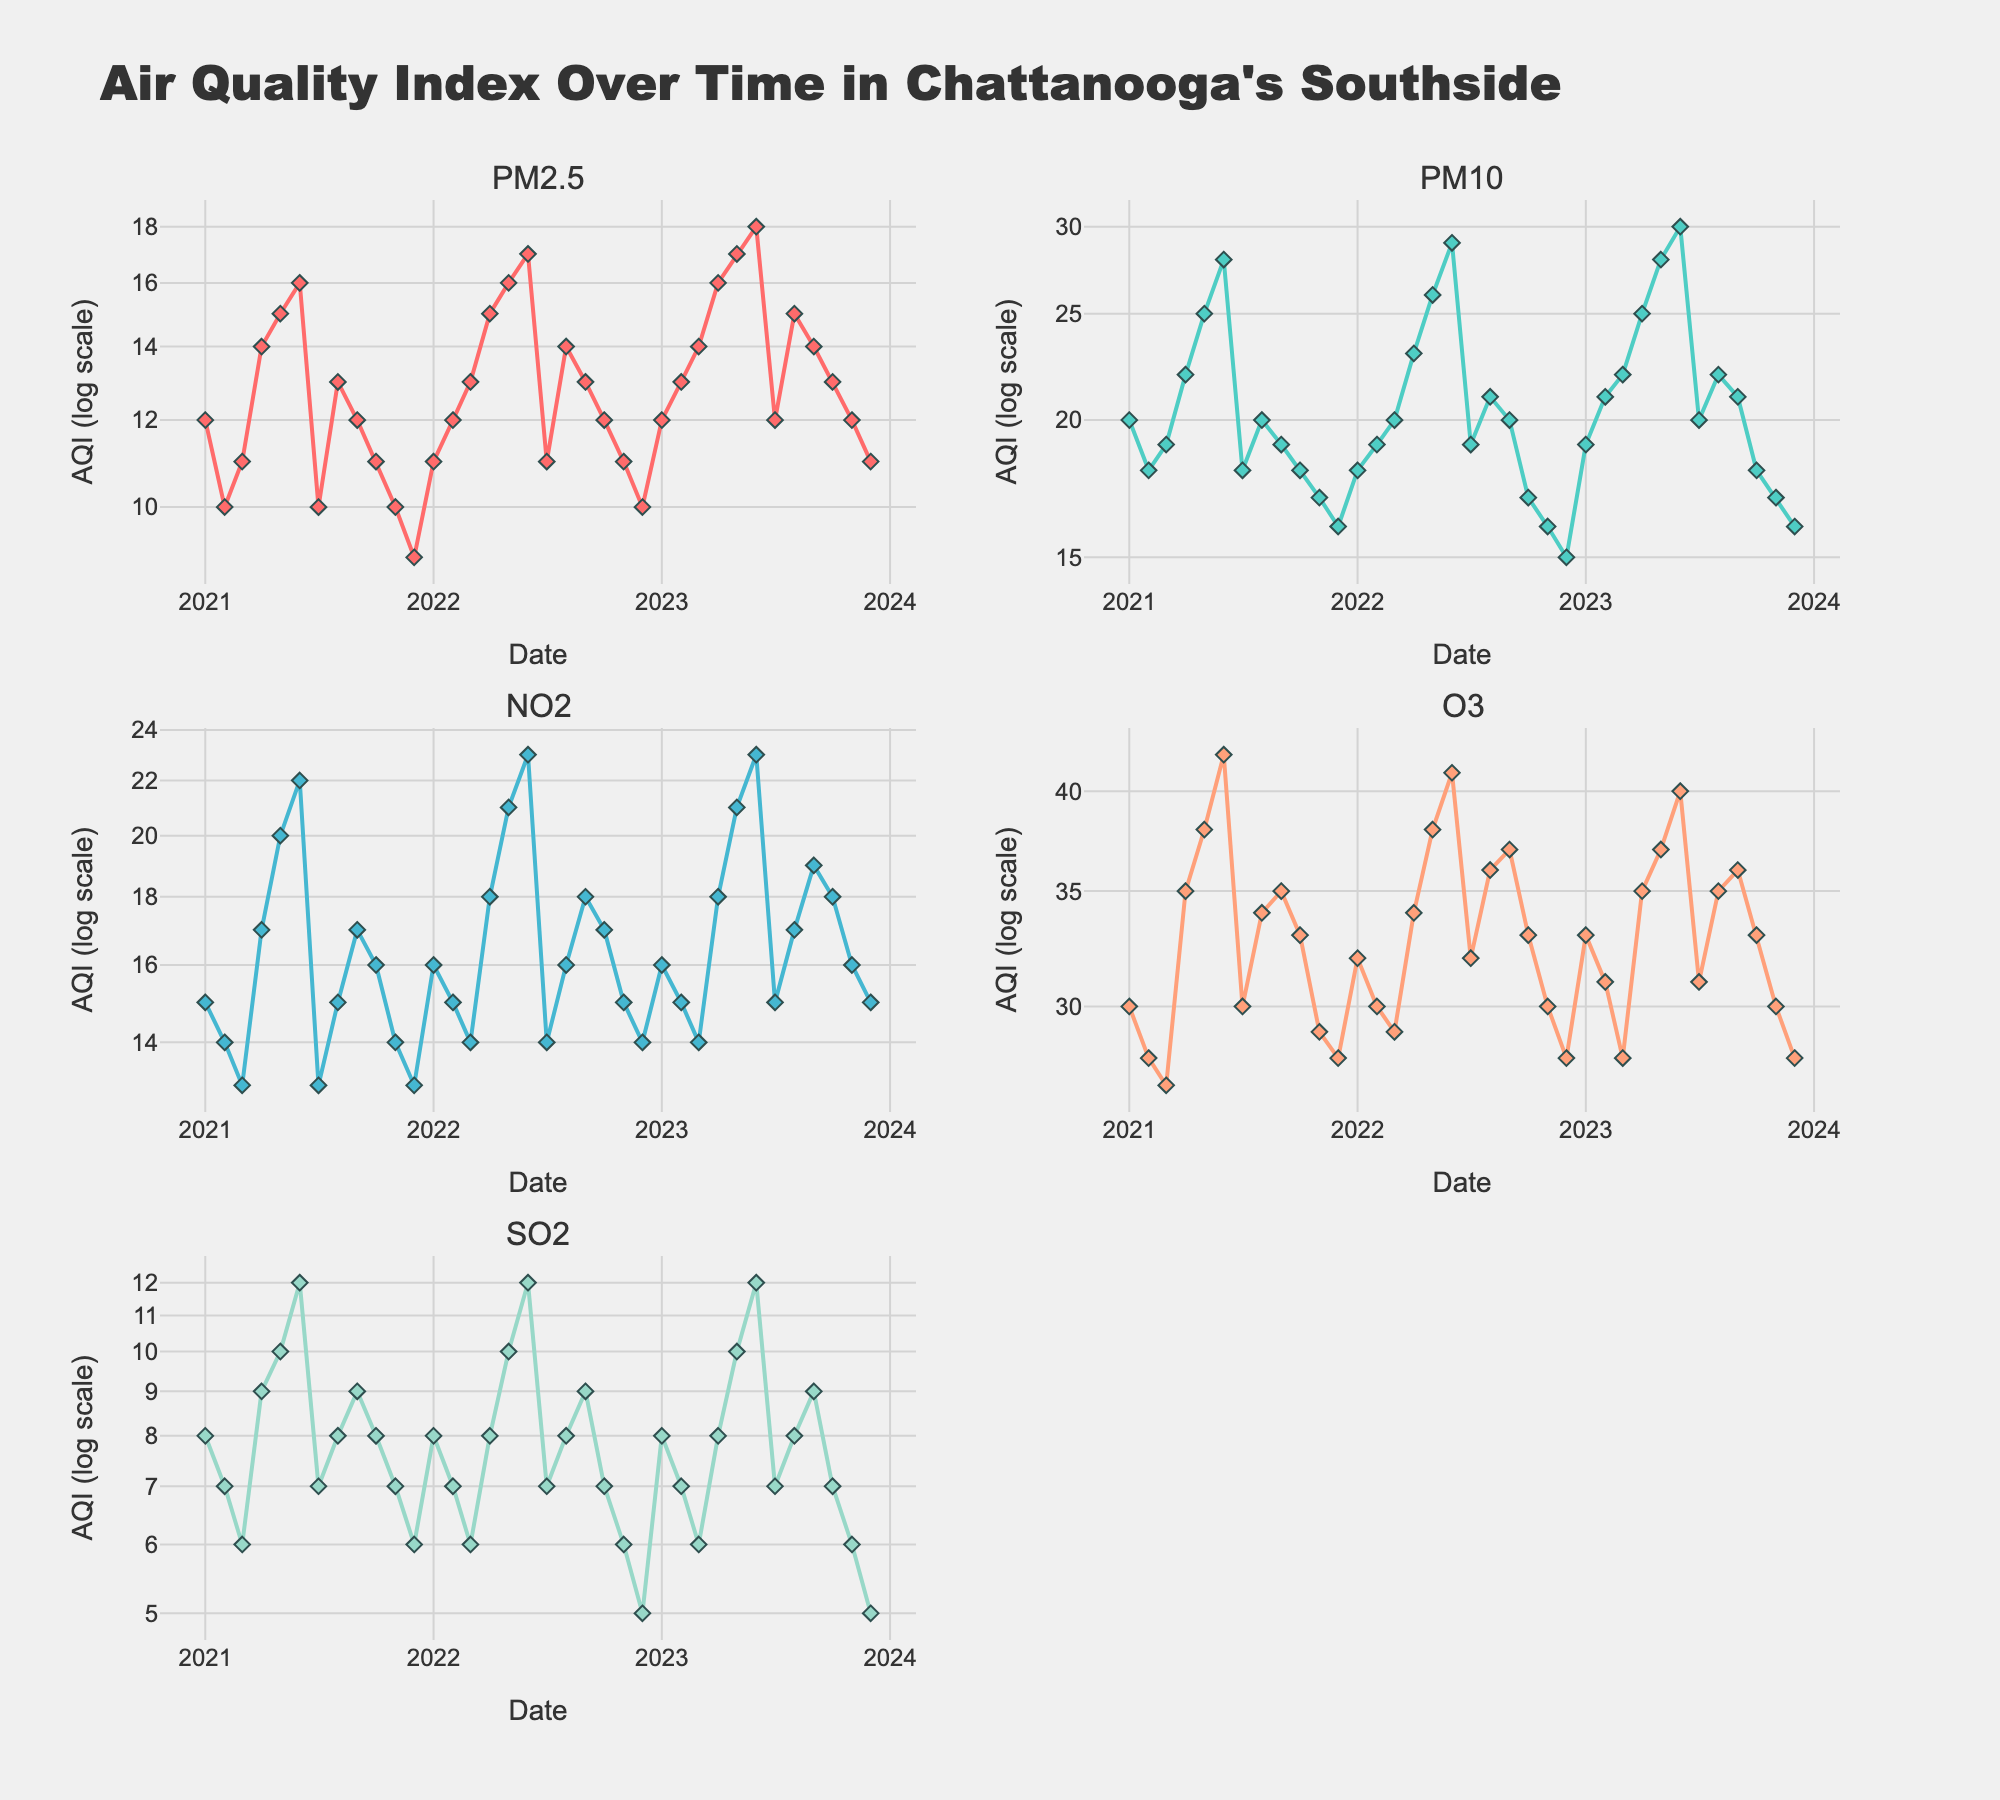What is the title of the plot? The title of the plot is located at the top of the figure, which provides an overview of what the plot represents.
Answer: Air Quality Index Over Time in Chattanooga's Southside What pollutants are measured in the subplots? The subplot titles indicate which pollutant is shown in each subplot.
Answer: PM2.5, PM10, NO2, O3, SO2 Which pollutant has the highest values in June 2023? Locate June 2023 on the x-axis of each subplot and check the y-axis values to determine which pollutant has the highest value.
Answer: PM10 How does the AQI for PM2.5 in January 2021 compare to January 2023? Check the y-axis for the subplot showing PM2.5 and compare the AQI values for January 2021 and January 2023.
Answer: Higher in January 2023 What is the general trend for O3 levels from January 2021 to December 2023? Observe the O3 subplot and follow the line from January 2021 to December 2023 to determine if the trend is increasing, decreasing, or remaining stable.
Answer: Fluctuating with a decreasing trend During which month and year does NO2 have its maximum value, and what is it? Check the NO2 subplot for the point with the highest y-axis value and read its corresponding x-axis value.
Answer: June 2023, 23 In which months of 2022 did PM10 levels exceed 20? Look at the PM10 subplot, locate the points above 20 on the y-axis, and note the corresponding months in 2022.
Answer: April, May, June, August What is the typical range of SO2 levels across the observed period? Observe the SO2 subplot to identify the lowest and highest y-axis values for SO2 between January 2021 and December 2023.
Answer: 5 to 12 Is there any noticeable seasonal pattern for NO2 levels? Check the NO2 subplot for repeating patterns across months in each year to identify any seasonal characteristics.
Answer: Higher in spring and summer Compare the O3 levels between May of each year. How do they change over time? Look at the O3 subplot and compare the y-axis values for May 2021, 2022, and 2023.
Answer: Increasing 